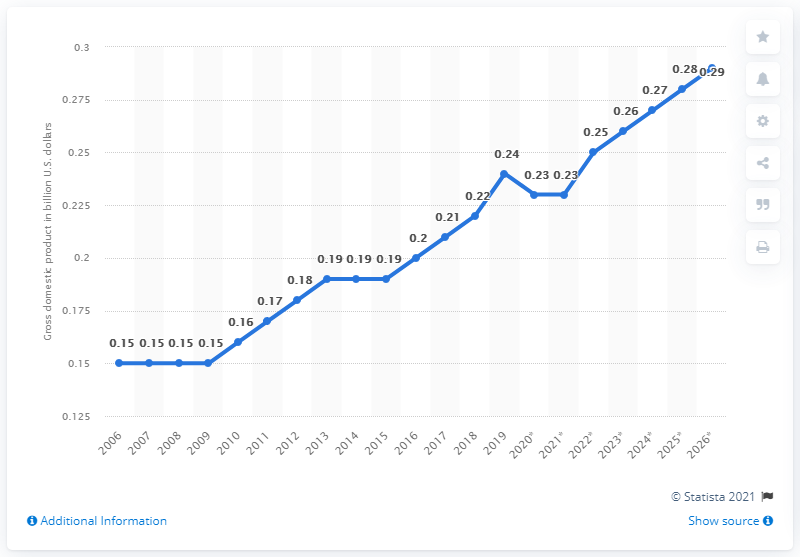Highlight a few significant elements in this photo. In 2019, the gross domestic product of the Marshall Islands was 0.24. 